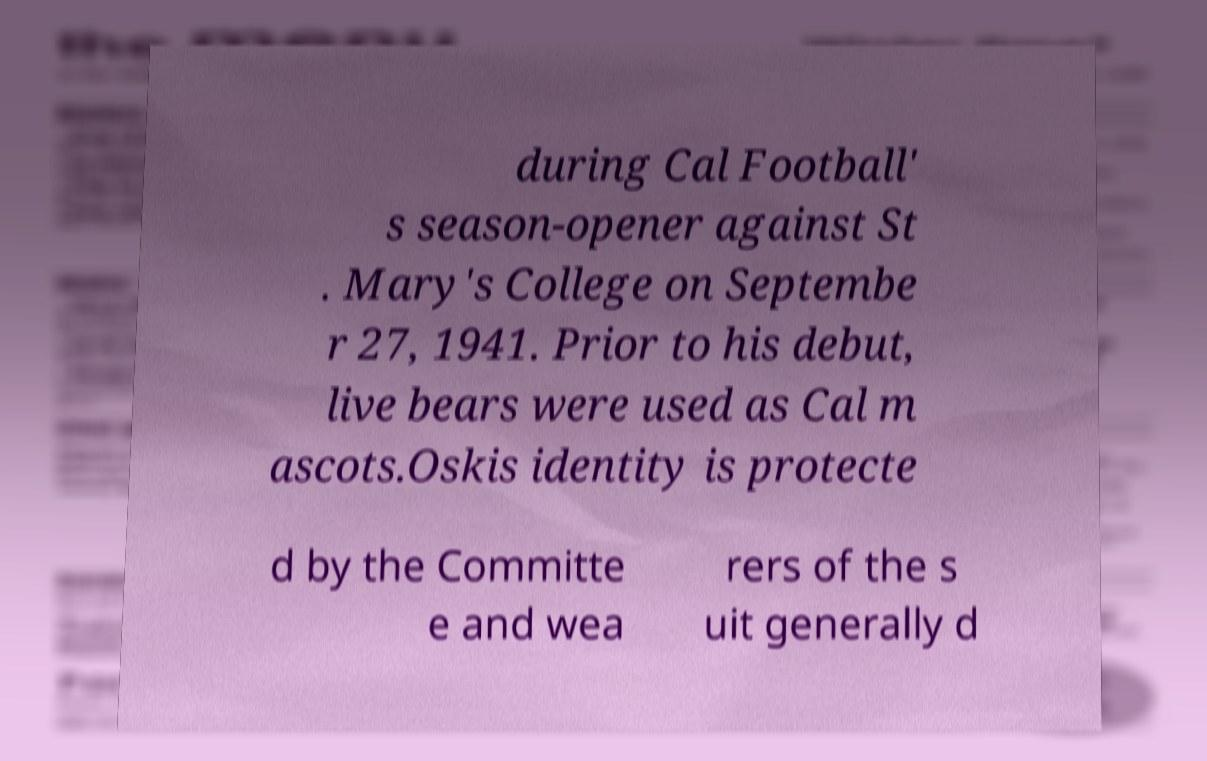Please identify and transcribe the text found in this image. during Cal Football' s season-opener against St . Mary's College on Septembe r 27, 1941. Prior to his debut, live bears were used as Cal m ascots.Oskis identity is protecte d by the Committe e and wea rers of the s uit generally d 